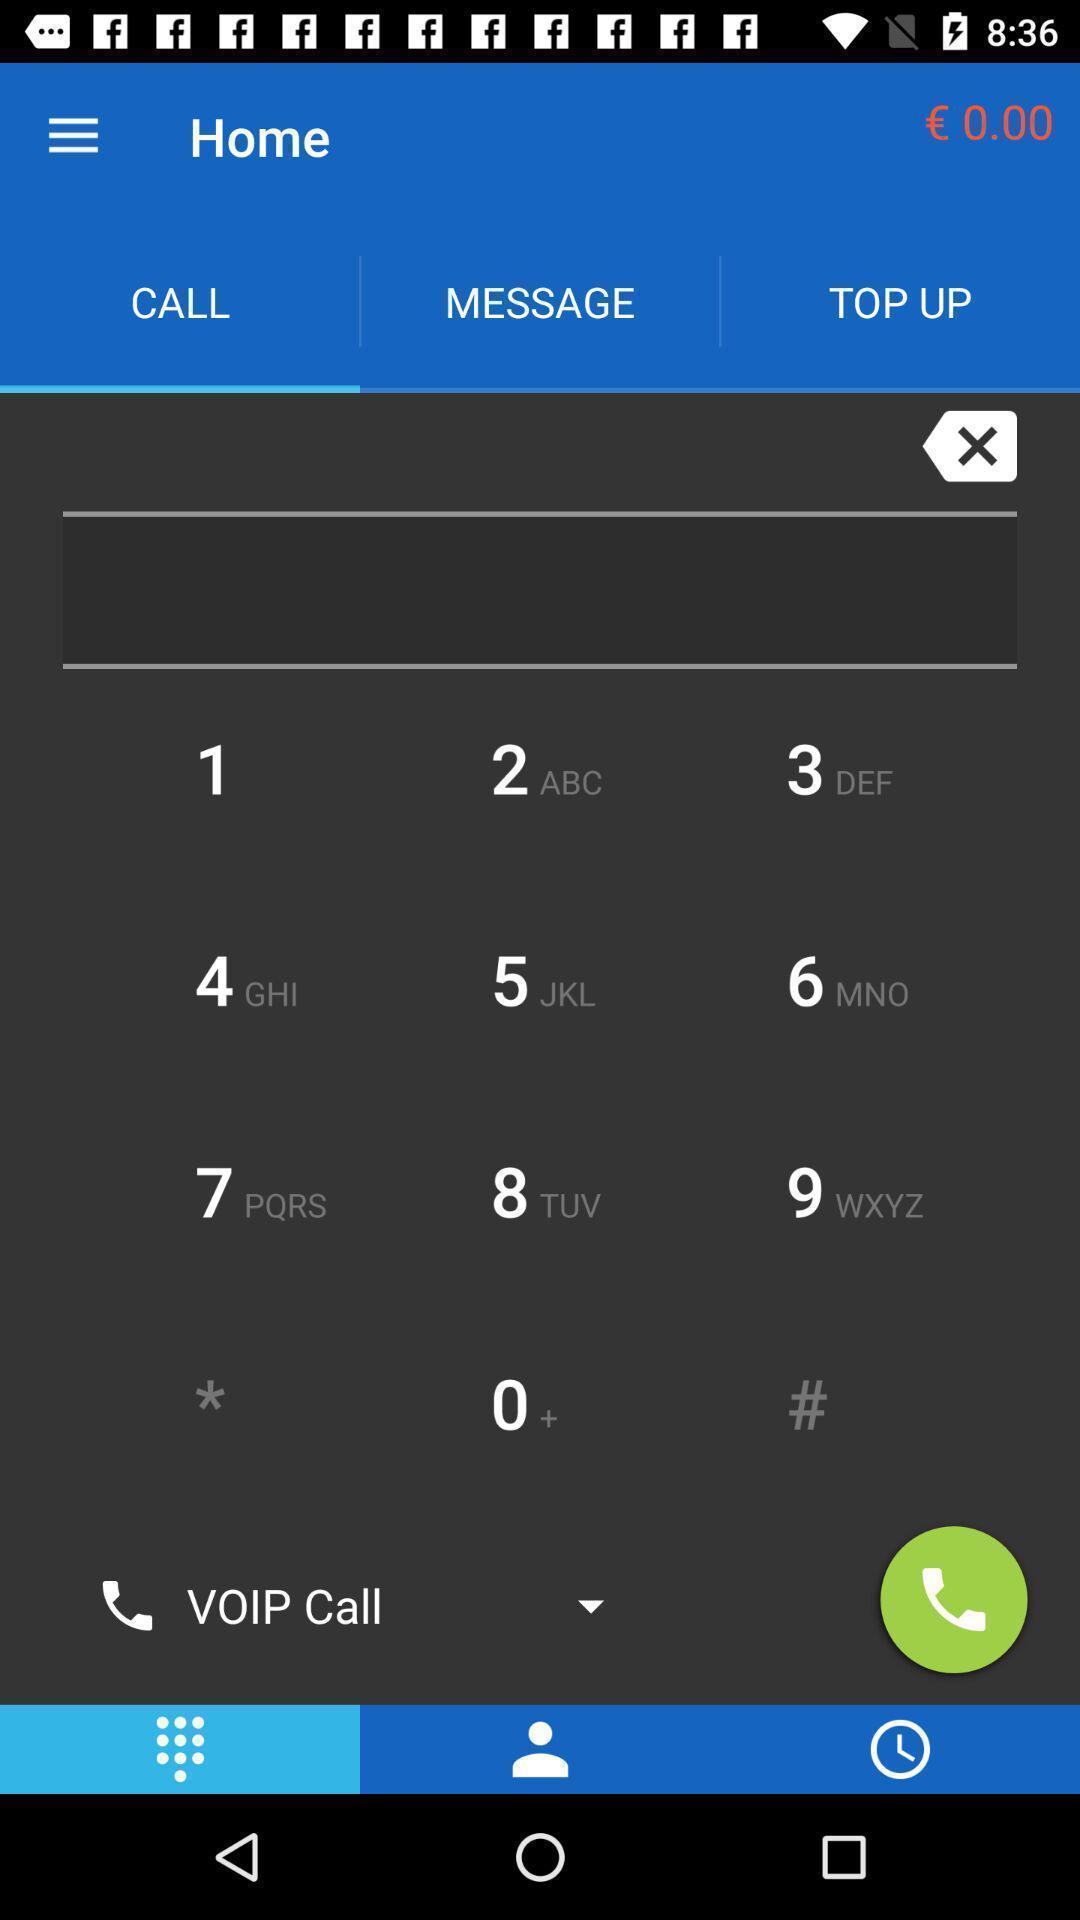Describe the key features of this screenshot. Window displaying a keypad page. 